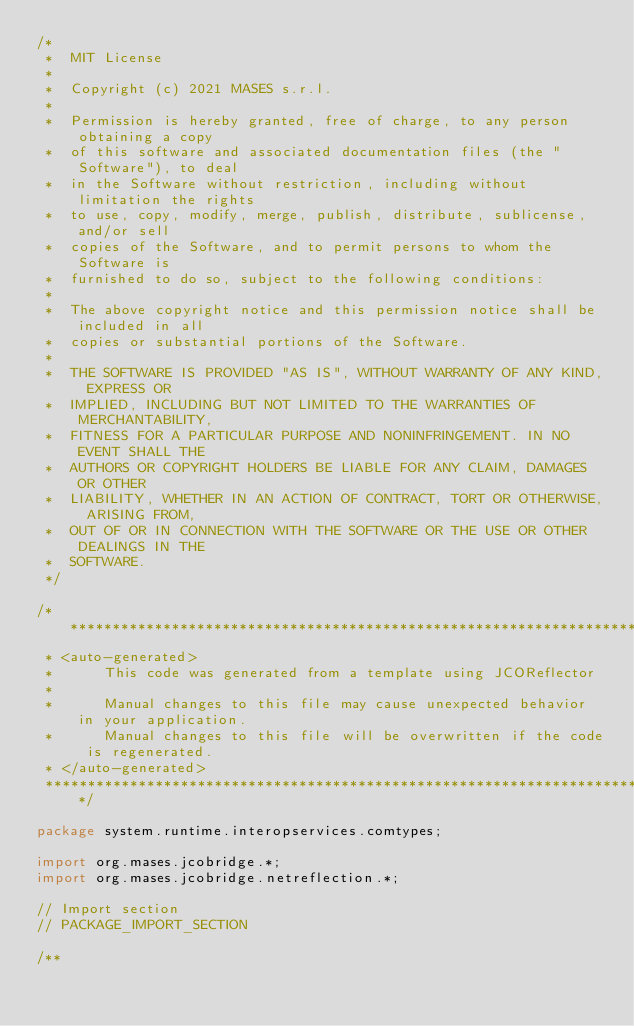<code> <loc_0><loc_0><loc_500><loc_500><_Java_>/*
 *  MIT License
 *
 *  Copyright (c) 2021 MASES s.r.l.
 *
 *  Permission is hereby granted, free of charge, to any person obtaining a copy
 *  of this software and associated documentation files (the "Software"), to deal
 *  in the Software without restriction, including without limitation the rights
 *  to use, copy, modify, merge, publish, distribute, sublicense, and/or sell
 *  copies of the Software, and to permit persons to whom the Software is
 *  furnished to do so, subject to the following conditions:
 *
 *  The above copyright notice and this permission notice shall be included in all
 *  copies or substantial portions of the Software.
 *
 *  THE SOFTWARE IS PROVIDED "AS IS", WITHOUT WARRANTY OF ANY KIND, EXPRESS OR
 *  IMPLIED, INCLUDING BUT NOT LIMITED TO THE WARRANTIES OF MERCHANTABILITY,
 *  FITNESS FOR A PARTICULAR PURPOSE AND NONINFRINGEMENT. IN NO EVENT SHALL THE
 *  AUTHORS OR COPYRIGHT HOLDERS BE LIABLE FOR ANY CLAIM, DAMAGES OR OTHER
 *  LIABILITY, WHETHER IN AN ACTION OF CONTRACT, TORT OR OTHERWISE, ARISING FROM,
 *  OUT OF OR IN CONNECTION WITH THE SOFTWARE OR THE USE OR OTHER DEALINGS IN THE
 *  SOFTWARE.
 */

/**************************************************************************************
 * <auto-generated>
 *      This code was generated from a template using JCOReflector
 * 
 *      Manual changes to this file may cause unexpected behavior in your application.
 *      Manual changes to this file will be overwritten if the code is regenerated.
 * </auto-generated>
 *************************************************************************************/

package system.runtime.interopservices.comtypes;

import org.mases.jcobridge.*;
import org.mases.jcobridge.netreflection.*;

// Import section
// PACKAGE_IMPORT_SECTION

/**</code> 